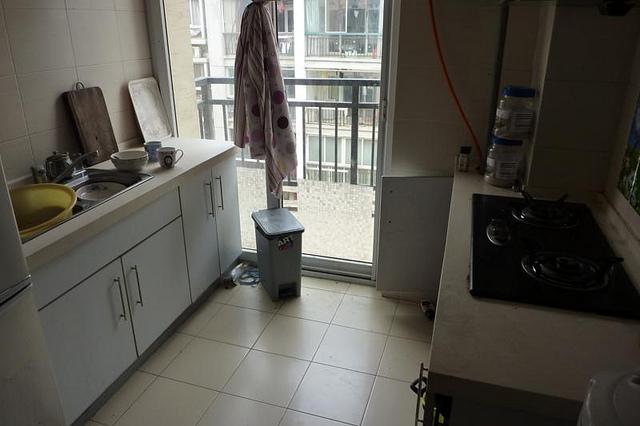How many cutting boards are shown?
Short answer required. 2. How many frying pans could be used simultaneously?
Answer briefly. 2. Would you cook in this room?
Keep it brief. Yes. Is something cooking on the stove?
Be succinct. No. What is in the sink?
Give a very brief answer. Dishes. 